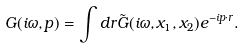Convert formula to latex. <formula><loc_0><loc_0><loc_500><loc_500>G ( i \omega , p ) = \int d r \tilde { G } ( i \omega , x _ { 1 } , x _ { 2 } ) e ^ { - i p \cdot r } .</formula> 